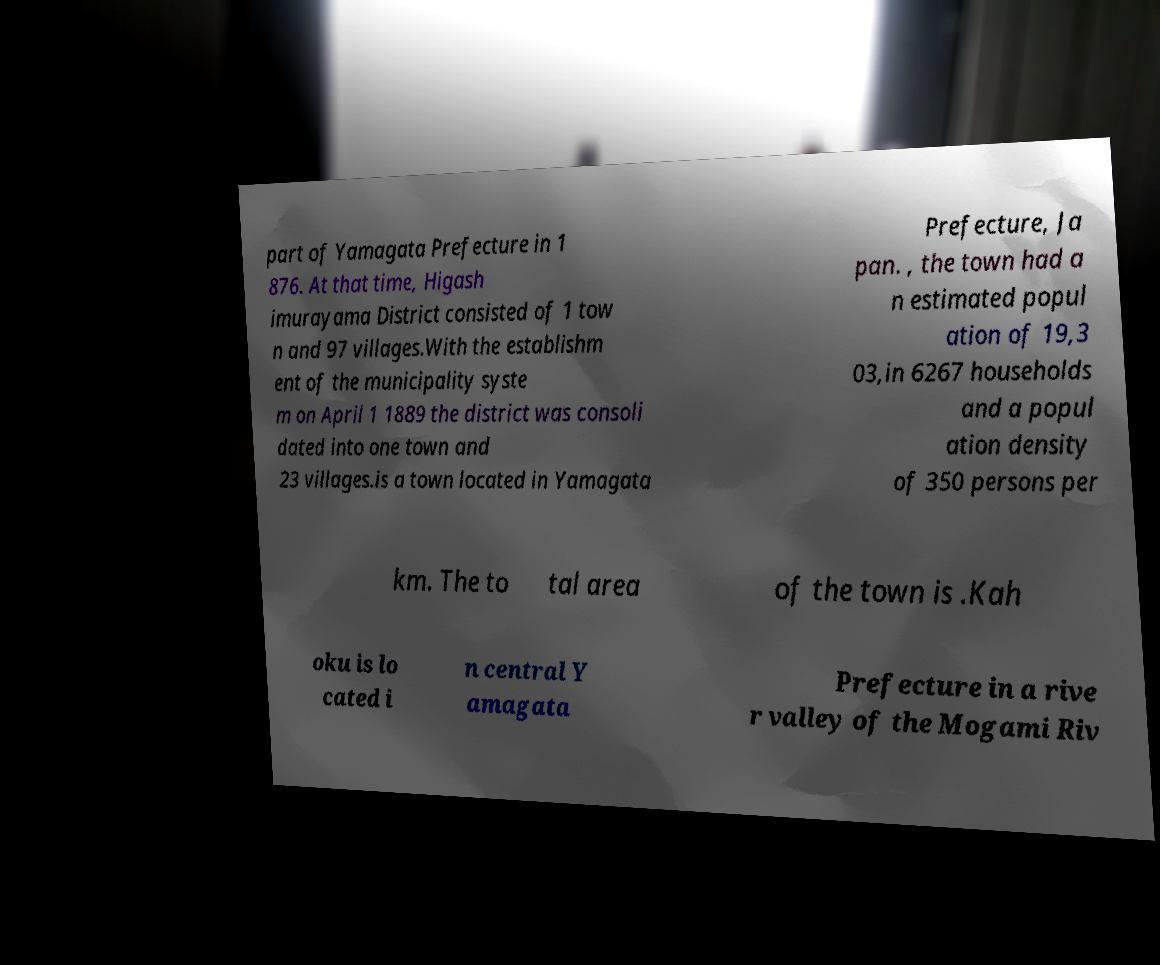Can you accurately transcribe the text from the provided image for me? part of Yamagata Prefecture in 1 876. At that time, Higash imurayama District consisted of 1 tow n and 97 villages.With the establishm ent of the municipality syste m on April 1 1889 the district was consoli dated into one town and 23 villages.is a town located in Yamagata Prefecture, Ja pan. , the town had a n estimated popul ation of 19,3 03,in 6267 households and a popul ation density of 350 persons per km. The to tal area of the town is .Kah oku is lo cated i n central Y amagata Prefecture in a rive r valley of the Mogami Riv 